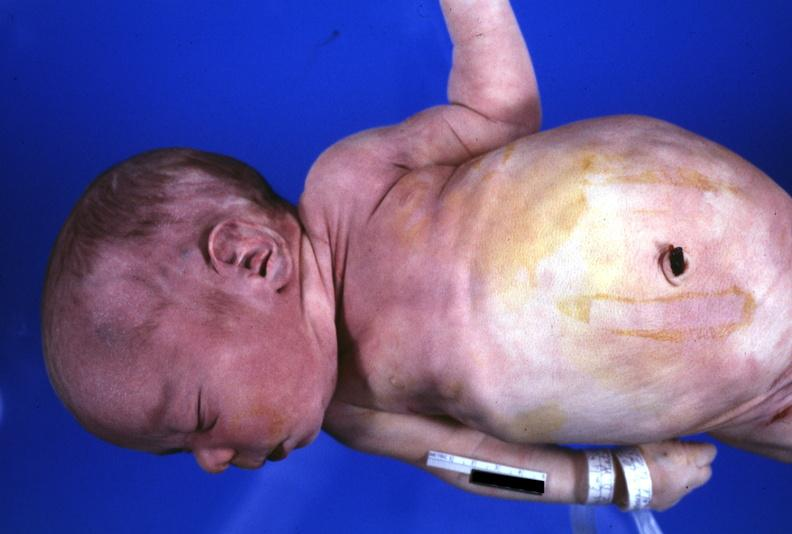does this image show view of low set ears?
Answer the question using a single word or phrase. Yes 